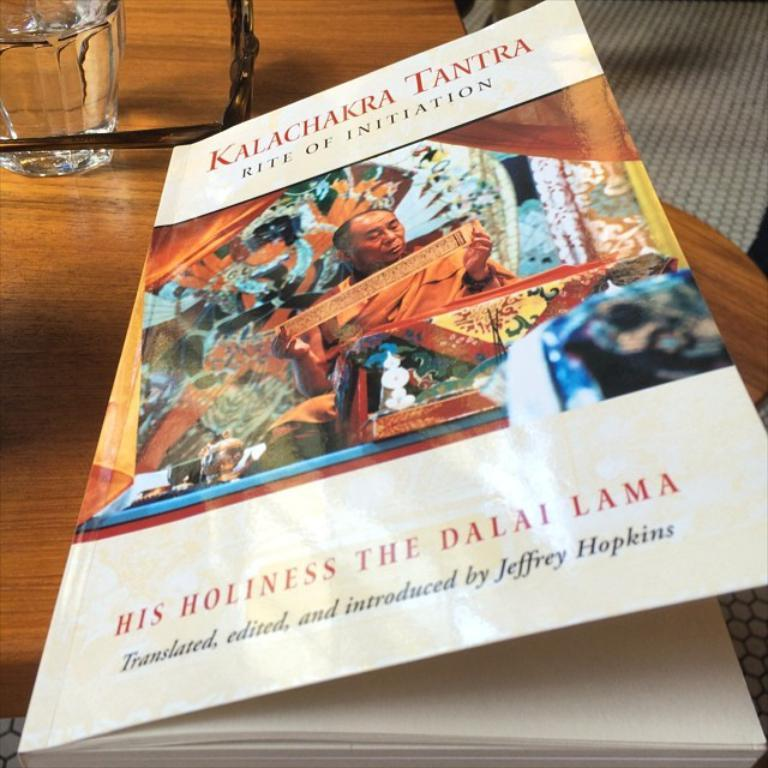<image>
Provide a brief description of the given image. a book partially opened with the title Kalachakra Tantra 